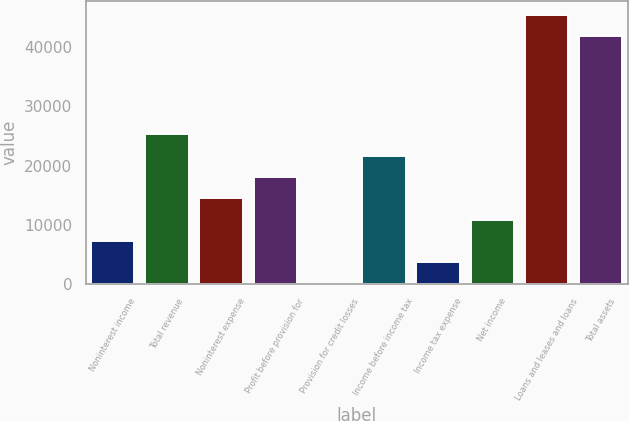<chart> <loc_0><loc_0><loc_500><loc_500><bar_chart><fcel>Noninterest income<fcel>Total revenue<fcel>Noninterest expense<fcel>Profit before provision for<fcel>Provision for credit losses<fcel>Income before income tax<fcel>Income tax expense<fcel>Net income<fcel>Loans and leases and loans<fcel>Total assets<nl><fcel>7236.6<fcel>25310.6<fcel>14466.2<fcel>18081<fcel>7<fcel>21695.8<fcel>3621.8<fcel>10851.4<fcel>45491.4<fcel>41876.6<nl></chart> 